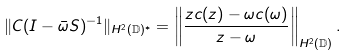<formula> <loc_0><loc_0><loc_500><loc_500>\| C ( I - \bar { \omega } S ) ^ { - 1 } \| _ { H ^ { 2 } ( \mathbb { D } ) ^ { * } } = \left \| \frac { z c ( z ) - \omega c ( \omega ) } { z - \omega } \right \| _ { H ^ { 2 } ( \mathbb { D } ) } .</formula> 